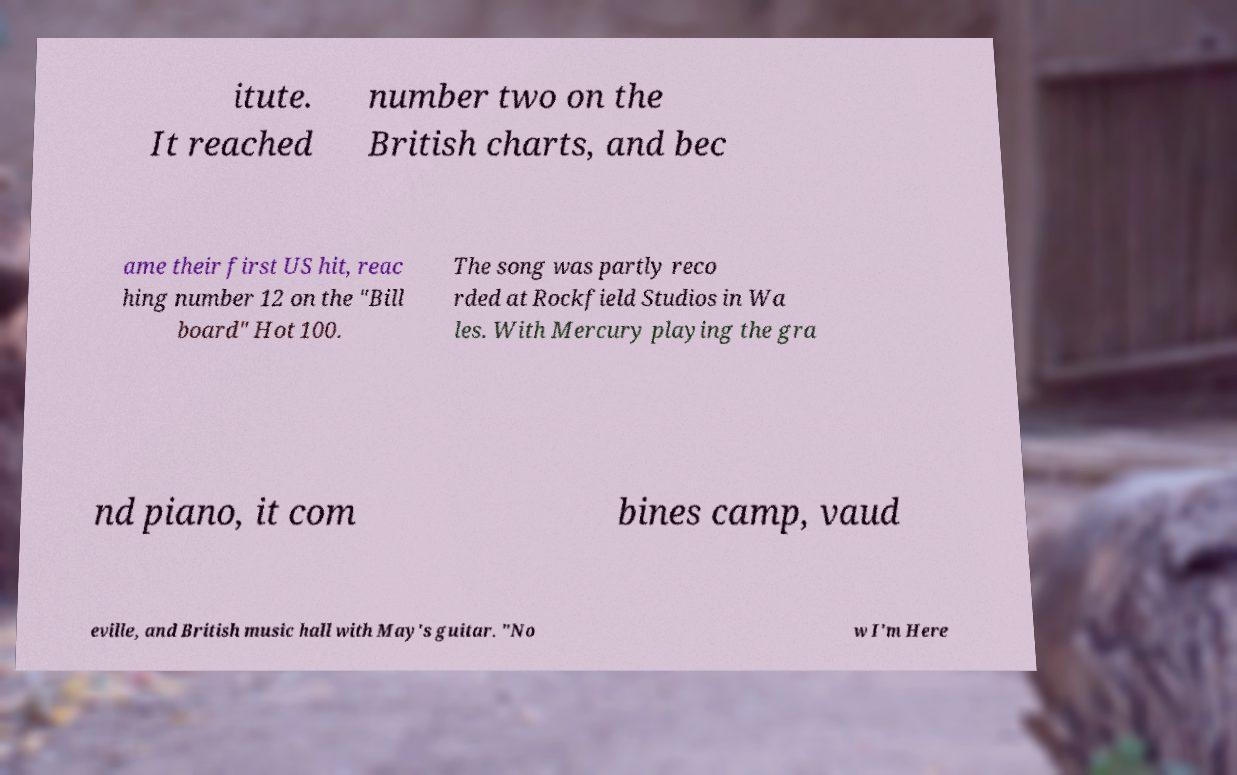What messages or text are displayed in this image? I need them in a readable, typed format. itute. It reached number two on the British charts, and bec ame their first US hit, reac hing number 12 on the "Bill board" Hot 100. The song was partly reco rded at Rockfield Studios in Wa les. With Mercury playing the gra nd piano, it com bines camp, vaud eville, and British music hall with May's guitar. "No w I'm Here 